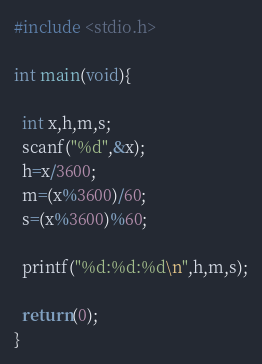<code> <loc_0><loc_0><loc_500><loc_500><_C_>#include <stdio.h>

int main(void){

  int x,h,m,s;
  scanf("%d",&x);
  h=x/3600;
  m=(x%3600)/60;
  s=(x%3600)%60;

  printf("%d:%d:%d\n",h,m,s);

  return(0);
}</code> 